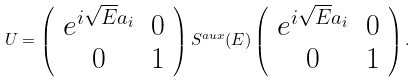<formula> <loc_0><loc_0><loc_500><loc_500>U = \left ( \begin{array} { c c } e ^ { i \sqrt { E } a _ { i } } & 0 \\ 0 & 1 \end{array} \right ) S ^ { a u x } ( E ) \left ( \begin{array} { c c } e ^ { i \sqrt { E } a _ { i } } & 0 \\ 0 & 1 \end{array} \right ) .</formula> 